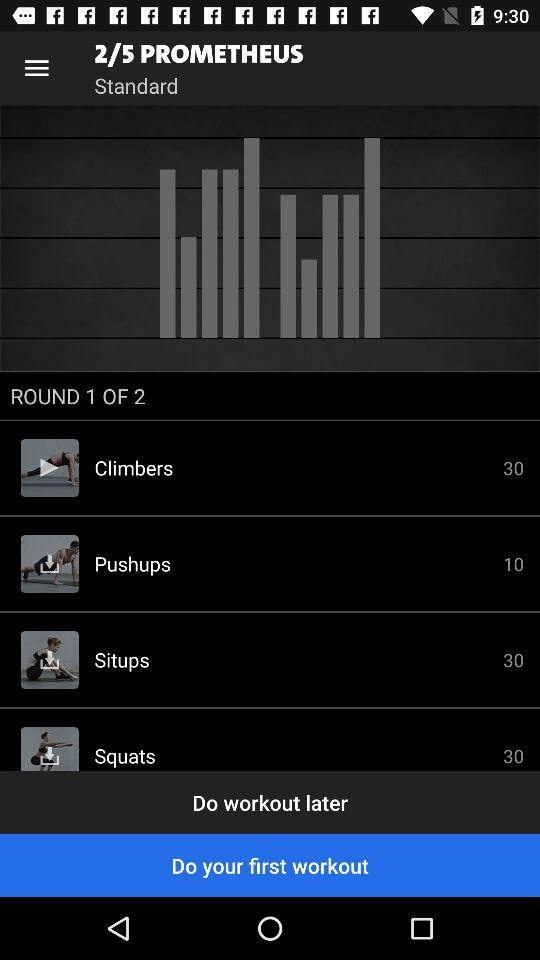What page are we on? We are on page 2. 